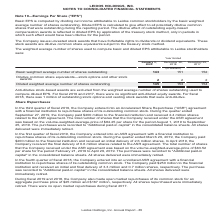According to Leidos Holdings's financial document, How is the Basic EPS calculated? by dividing net income attributable to Leidos common stockholders by the basic weighted average number of shares outstanding. The document states: "Basic EPS is computed by dividing net income attributable to Leidos common stockholders by the basic weighted average number of shares outstanding. Di..." Also, What was the outstanding stock options and vested stock awards in 2018? According to the financial document, 1 million. The relevant text states: "diluted equity awards. For fiscal 2018, there was 1 million of outstanding stock options and vesting stock awards that were anti-dilutive...." Also, What was the Basic weighted average number of shares outstanding in 2020, 2018 and 2017 respectively? The document contains multiple relevant values: 143, 151, 152 (in millions). From the document: "hted average number of shares outstanding 143 151 152 Dilutive common share equivalents—stock options and other stock awards 2 2 2 Diluted weighted av..." Additionally, In which year was Diluted weighted average number of shares outstanding less than 150 million? According to the financial document, 2020. The relevant text states: "January 3, 2020 December 28, 2018 December 29, 2017..." Also, can you calculate: What was the change in the Basic weighted average number of shares outstanding from 2017 to 2018? Based on the calculation: 151 - 152, the result is -1 (in millions). This is based on the information: "hted average number of shares outstanding 143 151 152 Dilutive common share equivalents—stock options and other stock awards 2 2 2 Diluted weighted avera weighted average number of shares outstanding ..." The key data points involved are: 151, 152. Also, can you calculate: What was the change in the Diluted weighted average number of shares outstanding from 2017 to 2018? Based on the calculation: 153 - 154, the result is -1 (in millions). This is based on the information: "hted average number of shares outstanding 145 153 154 weighted average number of shares outstanding 145 153 154..." The key data points involved are: 153, 154. 